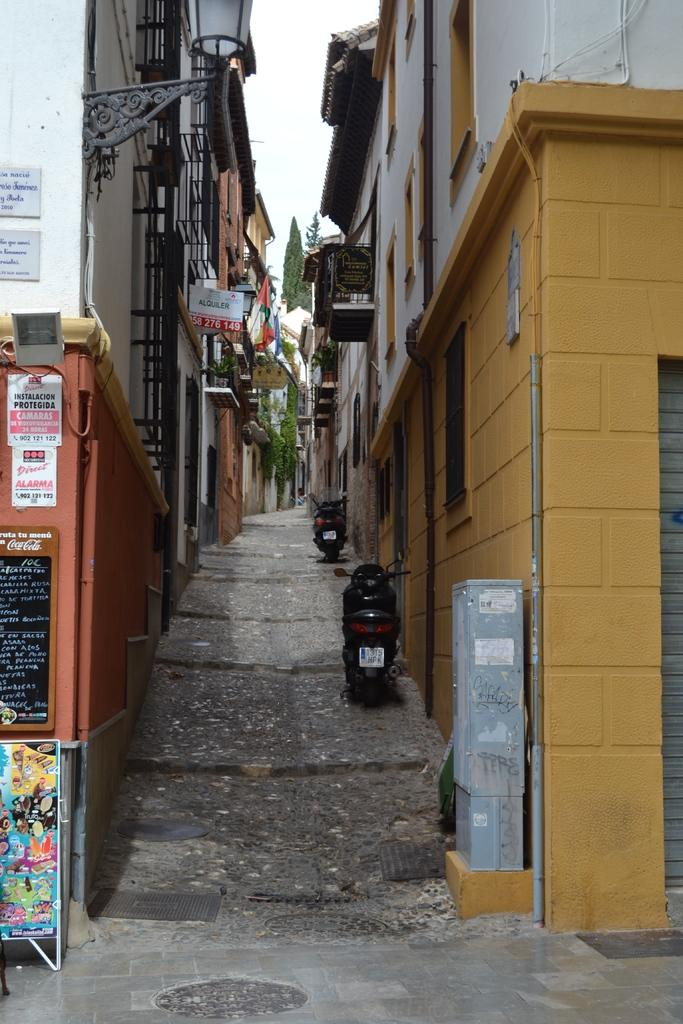What type of surface can be seen in the image? There is a path in the image. What structures are visible in the image? There are buildings in the image. What type of natural elements are present in the image? There are trees in the image. What man-made objects can be seen in the image? There are vehicles in the image. What type of signage is present in the image? There are boards with writing in the image. What type of religious ceremony is taking place in the image? There is no indication of a religious ceremony in the image; it features a path, buildings, trees, vehicles, and boards with writing. What type of liquid can be seen flowing through the image? There is no liquid present in the image. 